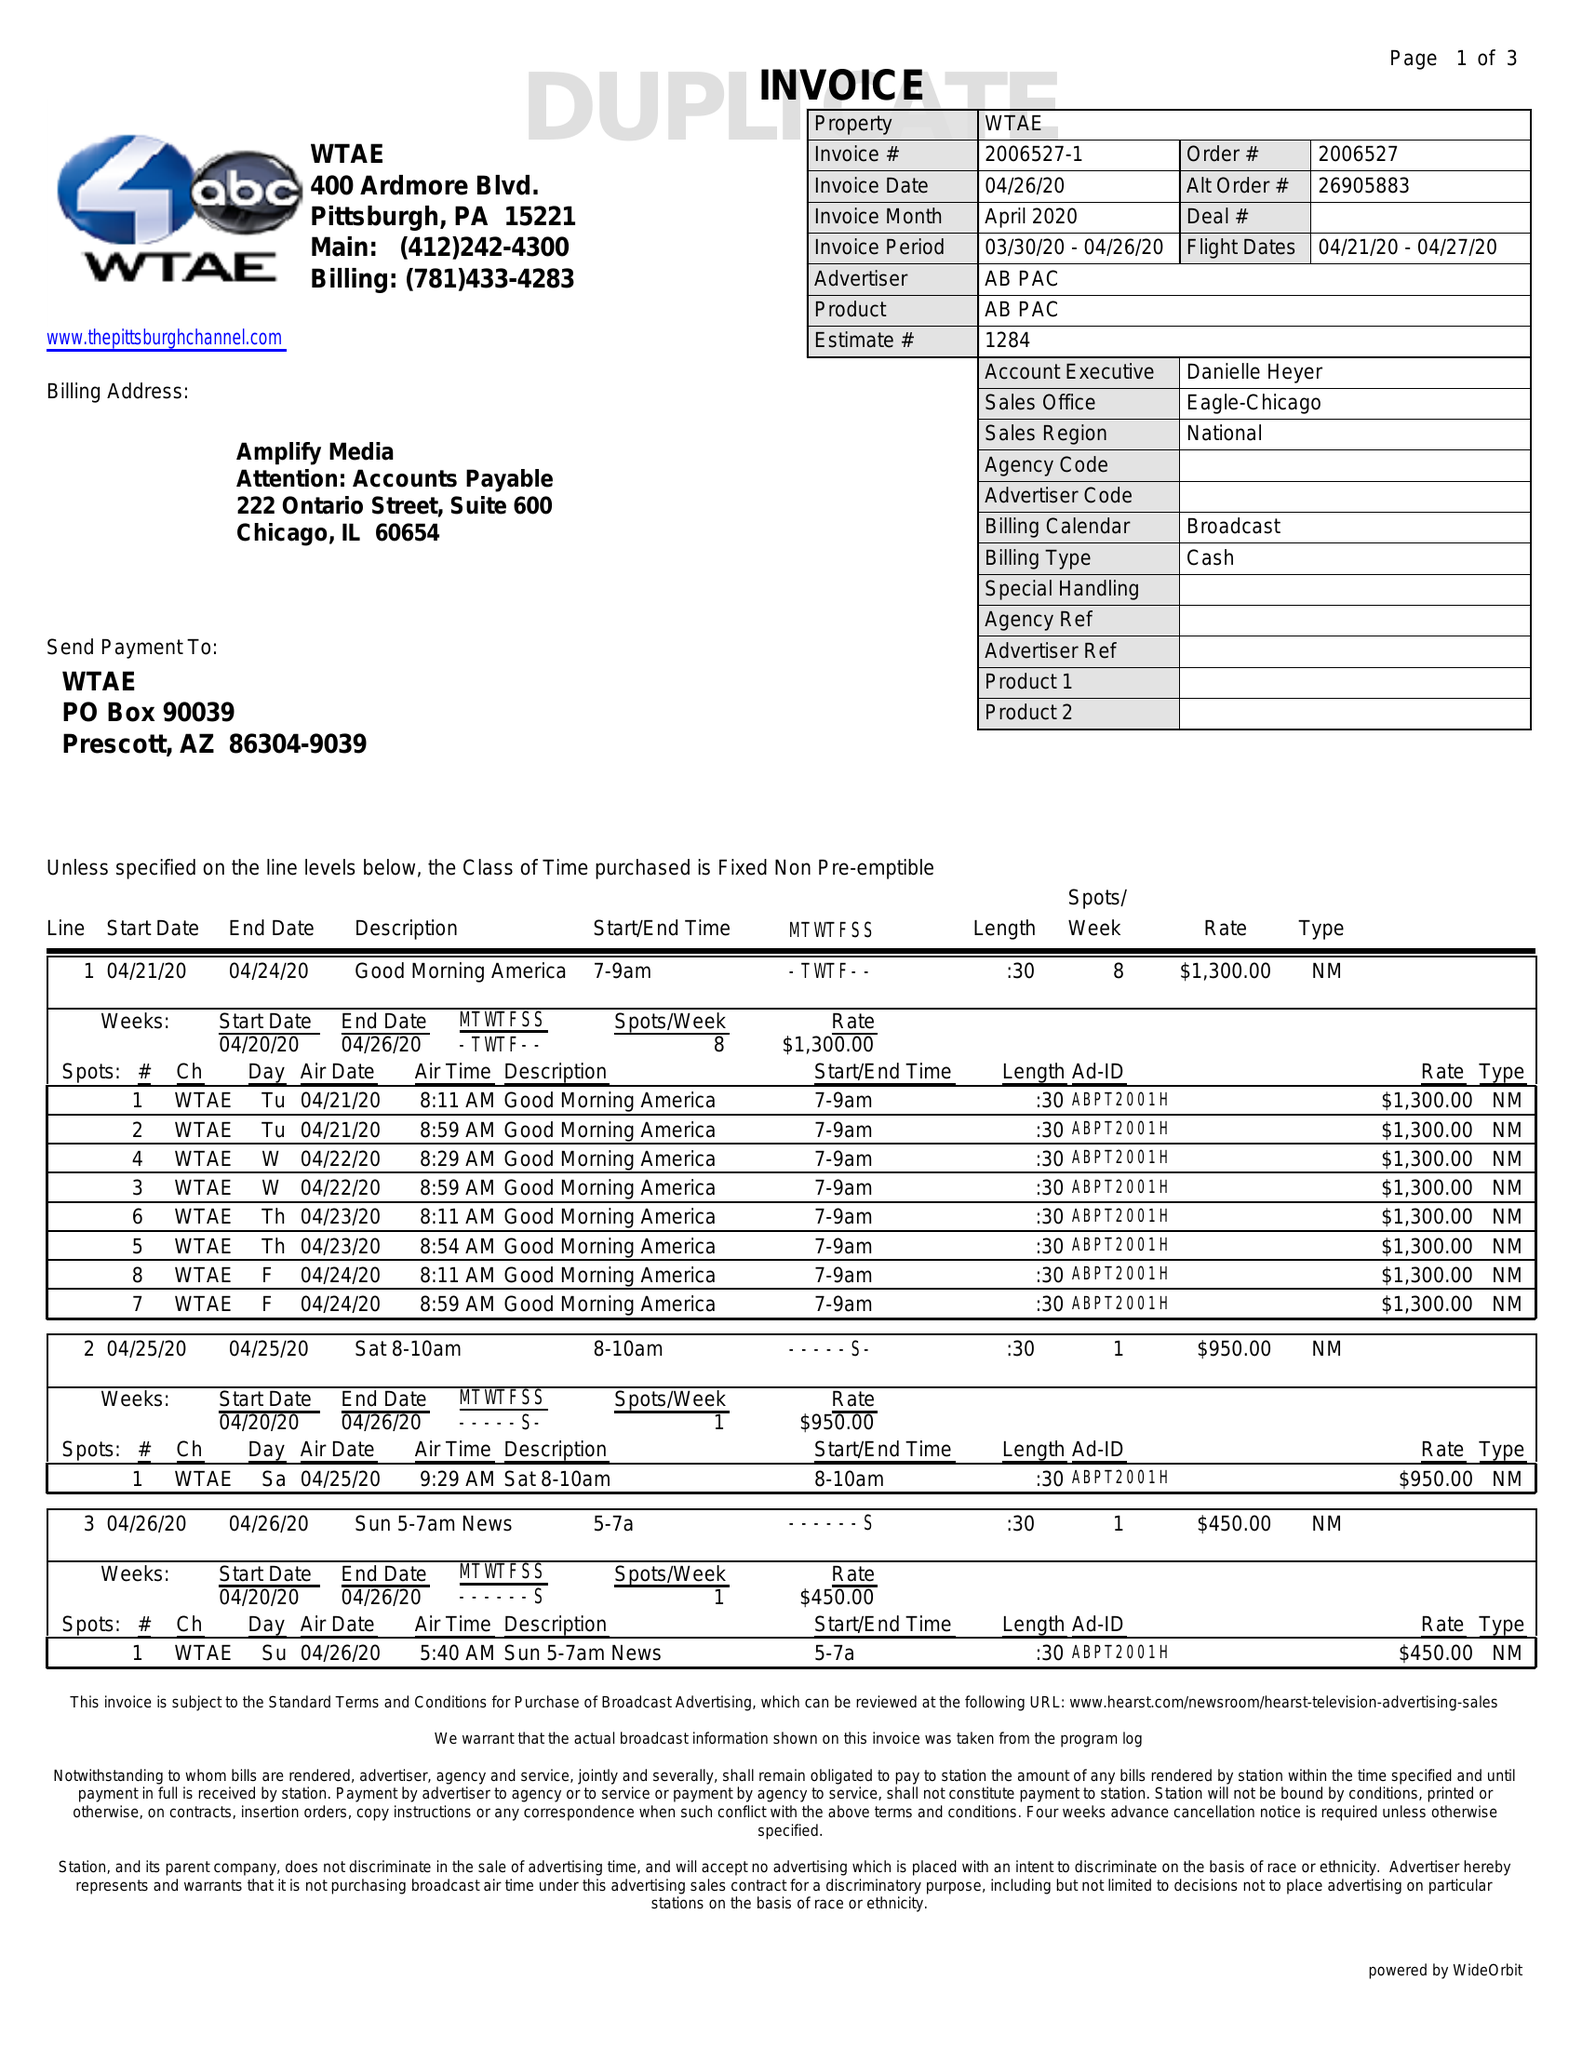What is the value for the gross_amount?
Answer the question using a single word or phrase. 44350.00 